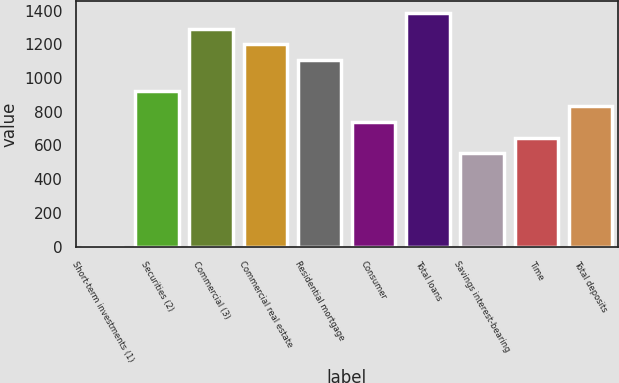Convert chart to OTSL. <chart><loc_0><loc_0><loc_500><loc_500><bar_chart><fcel>Short-term investments (1)<fcel>Securities (2)<fcel>Commercial (3)<fcel>Commercial real estate<fcel>Residential mortgage<fcel>Consumer<fcel>Total loans<fcel>Savings interest-bearing<fcel>Time<fcel>Total deposits<nl><fcel>0.3<fcel>923.6<fcel>1292.92<fcel>1200.59<fcel>1108.26<fcel>738.94<fcel>1385.25<fcel>554.28<fcel>646.61<fcel>831.27<nl></chart> 